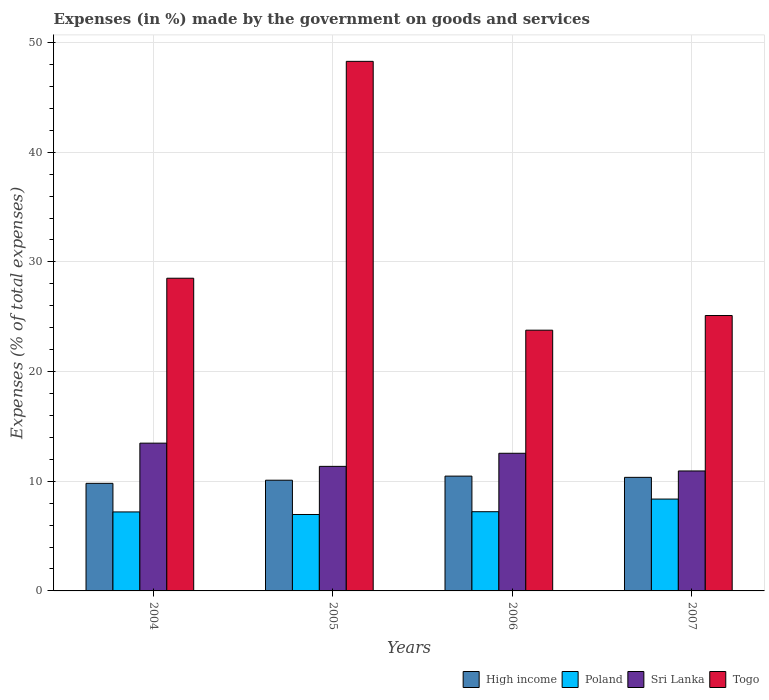How many groups of bars are there?
Your answer should be compact. 4. Are the number of bars per tick equal to the number of legend labels?
Your response must be concise. Yes. What is the label of the 1st group of bars from the left?
Offer a terse response. 2004. In how many cases, is the number of bars for a given year not equal to the number of legend labels?
Your response must be concise. 0. What is the percentage of expenses made by the government on goods and services in Poland in 2006?
Provide a succinct answer. 7.22. Across all years, what is the maximum percentage of expenses made by the government on goods and services in High income?
Offer a very short reply. 10.47. Across all years, what is the minimum percentage of expenses made by the government on goods and services in Togo?
Give a very brief answer. 23.77. In which year was the percentage of expenses made by the government on goods and services in High income minimum?
Your answer should be compact. 2004. What is the total percentage of expenses made by the government on goods and services in High income in the graph?
Ensure brevity in your answer.  40.73. What is the difference between the percentage of expenses made by the government on goods and services in Togo in 2004 and that in 2006?
Give a very brief answer. 4.74. What is the difference between the percentage of expenses made by the government on goods and services in High income in 2005 and the percentage of expenses made by the government on goods and services in Poland in 2004?
Make the answer very short. 2.89. What is the average percentage of expenses made by the government on goods and services in Poland per year?
Keep it short and to the point. 7.44. In the year 2007, what is the difference between the percentage of expenses made by the government on goods and services in Togo and percentage of expenses made by the government on goods and services in Sri Lanka?
Provide a succinct answer. 14.17. In how many years, is the percentage of expenses made by the government on goods and services in High income greater than 26 %?
Your answer should be very brief. 0. What is the ratio of the percentage of expenses made by the government on goods and services in Poland in 2004 to that in 2006?
Provide a short and direct response. 1. Is the percentage of expenses made by the government on goods and services in Sri Lanka in 2004 less than that in 2005?
Make the answer very short. No. Is the difference between the percentage of expenses made by the government on goods and services in Togo in 2005 and 2007 greater than the difference between the percentage of expenses made by the government on goods and services in Sri Lanka in 2005 and 2007?
Your response must be concise. Yes. What is the difference between the highest and the second highest percentage of expenses made by the government on goods and services in High income?
Keep it short and to the point. 0.11. What is the difference between the highest and the lowest percentage of expenses made by the government on goods and services in Togo?
Your answer should be compact. 24.51. Is the sum of the percentage of expenses made by the government on goods and services in Togo in 2004 and 2006 greater than the maximum percentage of expenses made by the government on goods and services in Sri Lanka across all years?
Ensure brevity in your answer.  Yes. Is it the case that in every year, the sum of the percentage of expenses made by the government on goods and services in Togo and percentage of expenses made by the government on goods and services in High income is greater than the sum of percentage of expenses made by the government on goods and services in Sri Lanka and percentage of expenses made by the government on goods and services in Poland?
Keep it short and to the point. Yes. What does the 3rd bar from the left in 2006 represents?
Offer a terse response. Sri Lanka. How many bars are there?
Provide a short and direct response. 16. Are all the bars in the graph horizontal?
Give a very brief answer. No. Are the values on the major ticks of Y-axis written in scientific E-notation?
Your response must be concise. No. Does the graph contain any zero values?
Your answer should be very brief. No. Does the graph contain grids?
Your answer should be very brief. Yes. Where does the legend appear in the graph?
Your response must be concise. Bottom right. How many legend labels are there?
Your response must be concise. 4. What is the title of the graph?
Give a very brief answer. Expenses (in %) made by the government on goods and services. Does "Swaziland" appear as one of the legend labels in the graph?
Your answer should be very brief. No. What is the label or title of the X-axis?
Make the answer very short. Years. What is the label or title of the Y-axis?
Your answer should be very brief. Expenses (% of total expenses). What is the Expenses (% of total expenses) in High income in 2004?
Offer a terse response. 9.81. What is the Expenses (% of total expenses) of Poland in 2004?
Your answer should be compact. 7.2. What is the Expenses (% of total expenses) in Sri Lanka in 2004?
Ensure brevity in your answer.  13.47. What is the Expenses (% of total expenses) in Togo in 2004?
Give a very brief answer. 28.51. What is the Expenses (% of total expenses) in High income in 2005?
Your answer should be compact. 10.09. What is the Expenses (% of total expenses) in Poland in 2005?
Provide a short and direct response. 6.97. What is the Expenses (% of total expenses) of Sri Lanka in 2005?
Your answer should be compact. 11.36. What is the Expenses (% of total expenses) in Togo in 2005?
Provide a short and direct response. 48.29. What is the Expenses (% of total expenses) of High income in 2006?
Your response must be concise. 10.47. What is the Expenses (% of total expenses) of Poland in 2006?
Ensure brevity in your answer.  7.22. What is the Expenses (% of total expenses) in Sri Lanka in 2006?
Give a very brief answer. 12.55. What is the Expenses (% of total expenses) in Togo in 2006?
Provide a short and direct response. 23.77. What is the Expenses (% of total expenses) of High income in 2007?
Keep it short and to the point. 10.36. What is the Expenses (% of total expenses) in Poland in 2007?
Your response must be concise. 8.37. What is the Expenses (% of total expenses) in Sri Lanka in 2007?
Provide a succinct answer. 10.94. What is the Expenses (% of total expenses) of Togo in 2007?
Keep it short and to the point. 25.11. Across all years, what is the maximum Expenses (% of total expenses) in High income?
Keep it short and to the point. 10.47. Across all years, what is the maximum Expenses (% of total expenses) in Poland?
Your answer should be compact. 8.37. Across all years, what is the maximum Expenses (% of total expenses) of Sri Lanka?
Your answer should be compact. 13.47. Across all years, what is the maximum Expenses (% of total expenses) in Togo?
Your answer should be very brief. 48.29. Across all years, what is the minimum Expenses (% of total expenses) in High income?
Offer a terse response. 9.81. Across all years, what is the minimum Expenses (% of total expenses) of Poland?
Provide a short and direct response. 6.97. Across all years, what is the minimum Expenses (% of total expenses) of Sri Lanka?
Ensure brevity in your answer.  10.94. Across all years, what is the minimum Expenses (% of total expenses) of Togo?
Your answer should be compact. 23.77. What is the total Expenses (% of total expenses) of High income in the graph?
Provide a short and direct response. 40.73. What is the total Expenses (% of total expenses) in Poland in the graph?
Ensure brevity in your answer.  29.77. What is the total Expenses (% of total expenses) in Sri Lanka in the graph?
Make the answer very short. 48.32. What is the total Expenses (% of total expenses) in Togo in the graph?
Provide a short and direct response. 125.68. What is the difference between the Expenses (% of total expenses) of High income in 2004 and that in 2005?
Provide a short and direct response. -0.29. What is the difference between the Expenses (% of total expenses) in Poland in 2004 and that in 2005?
Your answer should be very brief. 0.23. What is the difference between the Expenses (% of total expenses) in Sri Lanka in 2004 and that in 2005?
Make the answer very short. 2.12. What is the difference between the Expenses (% of total expenses) in Togo in 2004 and that in 2005?
Your response must be concise. -19.77. What is the difference between the Expenses (% of total expenses) of High income in 2004 and that in 2006?
Your answer should be very brief. -0.66. What is the difference between the Expenses (% of total expenses) of Poland in 2004 and that in 2006?
Keep it short and to the point. -0.02. What is the difference between the Expenses (% of total expenses) in Sri Lanka in 2004 and that in 2006?
Keep it short and to the point. 0.92. What is the difference between the Expenses (% of total expenses) of Togo in 2004 and that in 2006?
Make the answer very short. 4.74. What is the difference between the Expenses (% of total expenses) in High income in 2004 and that in 2007?
Give a very brief answer. -0.55. What is the difference between the Expenses (% of total expenses) in Poland in 2004 and that in 2007?
Offer a very short reply. -1.17. What is the difference between the Expenses (% of total expenses) of Sri Lanka in 2004 and that in 2007?
Keep it short and to the point. 2.53. What is the difference between the Expenses (% of total expenses) of Togo in 2004 and that in 2007?
Offer a terse response. 3.4. What is the difference between the Expenses (% of total expenses) of High income in 2005 and that in 2006?
Make the answer very short. -0.37. What is the difference between the Expenses (% of total expenses) of Poland in 2005 and that in 2006?
Keep it short and to the point. -0.25. What is the difference between the Expenses (% of total expenses) of Sri Lanka in 2005 and that in 2006?
Make the answer very short. -1.19. What is the difference between the Expenses (% of total expenses) of Togo in 2005 and that in 2006?
Your answer should be very brief. 24.51. What is the difference between the Expenses (% of total expenses) of High income in 2005 and that in 2007?
Keep it short and to the point. -0.26. What is the difference between the Expenses (% of total expenses) in Poland in 2005 and that in 2007?
Provide a short and direct response. -1.41. What is the difference between the Expenses (% of total expenses) of Sri Lanka in 2005 and that in 2007?
Keep it short and to the point. 0.42. What is the difference between the Expenses (% of total expenses) of Togo in 2005 and that in 2007?
Keep it short and to the point. 23.18. What is the difference between the Expenses (% of total expenses) of High income in 2006 and that in 2007?
Ensure brevity in your answer.  0.11. What is the difference between the Expenses (% of total expenses) in Poland in 2006 and that in 2007?
Offer a very short reply. -1.15. What is the difference between the Expenses (% of total expenses) of Sri Lanka in 2006 and that in 2007?
Your answer should be compact. 1.61. What is the difference between the Expenses (% of total expenses) of Togo in 2006 and that in 2007?
Your answer should be very brief. -1.34. What is the difference between the Expenses (% of total expenses) in High income in 2004 and the Expenses (% of total expenses) in Poland in 2005?
Your response must be concise. 2.84. What is the difference between the Expenses (% of total expenses) in High income in 2004 and the Expenses (% of total expenses) in Sri Lanka in 2005?
Offer a terse response. -1.55. What is the difference between the Expenses (% of total expenses) of High income in 2004 and the Expenses (% of total expenses) of Togo in 2005?
Provide a short and direct response. -38.48. What is the difference between the Expenses (% of total expenses) of Poland in 2004 and the Expenses (% of total expenses) of Sri Lanka in 2005?
Offer a very short reply. -4.15. What is the difference between the Expenses (% of total expenses) in Poland in 2004 and the Expenses (% of total expenses) in Togo in 2005?
Make the answer very short. -41.08. What is the difference between the Expenses (% of total expenses) of Sri Lanka in 2004 and the Expenses (% of total expenses) of Togo in 2005?
Offer a very short reply. -34.81. What is the difference between the Expenses (% of total expenses) of High income in 2004 and the Expenses (% of total expenses) of Poland in 2006?
Offer a very short reply. 2.59. What is the difference between the Expenses (% of total expenses) in High income in 2004 and the Expenses (% of total expenses) in Sri Lanka in 2006?
Your answer should be compact. -2.74. What is the difference between the Expenses (% of total expenses) of High income in 2004 and the Expenses (% of total expenses) of Togo in 2006?
Keep it short and to the point. -13.97. What is the difference between the Expenses (% of total expenses) of Poland in 2004 and the Expenses (% of total expenses) of Sri Lanka in 2006?
Your answer should be compact. -5.35. What is the difference between the Expenses (% of total expenses) of Poland in 2004 and the Expenses (% of total expenses) of Togo in 2006?
Your answer should be compact. -16.57. What is the difference between the Expenses (% of total expenses) in Sri Lanka in 2004 and the Expenses (% of total expenses) in Togo in 2006?
Keep it short and to the point. -10.3. What is the difference between the Expenses (% of total expenses) in High income in 2004 and the Expenses (% of total expenses) in Poland in 2007?
Provide a succinct answer. 1.43. What is the difference between the Expenses (% of total expenses) in High income in 2004 and the Expenses (% of total expenses) in Sri Lanka in 2007?
Provide a short and direct response. -1.13. What is the difference between the Expenses (% of total expenses) in High income in 2004 and the Expenses (% of total expenses) in Togo in 2007?
Offer a very short reply. -15.3. What is the difference between the Expenses (% of total expenses) in Poland in 2004 and the Expenses (% of total expenses) in Sri Lanka in 2007?
Ensure brevity in your answer.  -3.74. What is the difference between the Expenses (% of total expenses) in Poland in 2004 and the Expenses (% of total expenses) in Togo in 2007?
Your response must be concise. -17.91. What is the difference between the Expenses (% of total expenses) in Sri Lanka in 2004 and the Expenses (% of total expenses) in Togo in 2007?
Provide a short and direct response. -11.64. What is the difference between the Expenses (% of total expenses) of High income in 2005 and the Expenses (% of total expenses) of Poland in 2006?
Your answer should be very brief. 2.87. What is the difference between the Expenses (% of total expenses) of High income in 2005 and the Expenses (% of total expenses) of Sri Lanka in 2006?
Offer a very short reply. -2.46. What is the difference between the Expenses (% of total expenses) of High income in 2005 and the Expenses (% of total expenses) of Togo in 2006?
Ensure brevity in your answer.  -13.68. What is the difference between the Expenses (% of total expenses) in Poland in 2005 and the Expenses (% of total expenses) in Sri Lanka in 2006?
Give a very brief answer. -5.58. What is the difference between the Expenses (% of total expenses) in Poland in 2005 and the Expenses (% of total expenses) in Togo in 2006?
Offer a very short reply. -16.81. What is the difference between the Expenses (% of total expenses) in Sri Lanka in 2005 and the Expenses (% of total expenses) in Togo in 2006?
Provide a succinct answer. -12.42. What is the difference between the Expenses (% of total expenses) in High income in 2005 and the Expenses (% of total expenses) in Poland in 2007?
Keep it short and to the point. 1.72. What is the difference between the Expenses (% of total expenses) of High income in 2005 and the Expenses (% of total expenses) of Sri Lanka in 2007?
Your response must be concise. -0.84. What is the difference between the Expenses (% of total expenses) in High income in 2005 and the Expenses (% of total expenses) in Togo in 2007?
Keep it short and to the point. -15.02. What is the difference between the Expenses (% of total expenses) of Poland in 2005 and the Expenses (% of total expenses) of Sri Lanka in 2007?
Keep it short and to the point. -3.97. What is the difference between the Expenses (% of total expenses) in Poland in 2005 and the Expenses (% of total expenses) in Togo in 2007?
Provide a short and direct response. -18.14. What is the difference between the Expenses (% of total expenses) of Sri Lanka in 2005 and the Expenses (% of total expenses) of Togo in 2007?
Ensure brevity in your answer.  -13.75. What is the difference between the Expenses (% of total expenses) of High income in 2006 and the Expenses (% of total expenses) of Poland in 2007?
Give a very brief answer. 2.09. What is the difference between the Expenses (% of total expenses) in High income in 2006 and the Expenses (% of total expenses) in Sri Lanka in 2007?
Offer a terse response. -0.47. What is the difference between the Expenses (% of total expenses) of High income in 2006 and the Expenses (% of total expenses) of Togo in 2007?
Provide a succinct answer. -14.64. What is the difference between the Expenses (% of total expenses) of Poland in 2006 and the Expenses (% of total expenses) of Sri Lanka in 2007?
Provide a short and direct response. -3.72. What is the difference between the Expenses (% of total expenses) in Poland in 2006 and the Expenses (% of total expenses) in Togo in 2007?
Keep it short and to the point. -17.89. What is the difference between the Expenses (% of total expenses) in Sri Lanka in 2006 and the Expenses (% of total expenses) in Togo in 2007?
Your answer should be very brief. -12.56. What is the average Expenses (% of total expenses) of High income per year?
Your response must be concise. 10.18. What is the average Expenses (% of total expenses) of Poland per year?
Keep it short and to the point. 7.44. What is the average Expenses (% of total expenses) of Sri Lanka per year?
Your response must be concise. 12.08. What is the average Expenses (% of total expenses) in Togo per year?
Your response must be concise. 31.42. In the year 2004, what is the difference between the Expenses (% of total expenses) of High income and Expenses (% of total expenses) of Poland?
Your response must be concise. 2.61. In the year 2004, what is the difference between the Expenses (% of total expenses) in High income and Expenses (% of total expenses) in Sri Lanka?
Keep it short and to the point. -3.66. In the year 2004, what is the difference between the Expenses (% of total expenses) in High income and Expenses (% of total expenses) in Togo?
Provide a short and direct response. -18.7. In the year 2004, what is the difference between the Expenses (% of total expenses) in Poland and Expenses (% of total expenses) in Sri Lanka?
Keep it short and to the point. -6.27. In the year 2004, what is the difference between the Expenses (% of total expenses) in Poland and Expenses (% of total expenses) in Togo?
Keep it short and to the point. -21.31. In the year 2004, what is the difference between the Expenses (% of total expenses) in Sri Lanka and Expenses (% of total expenses) in Togo?
Provide a short and direct response. -15.04. In the year 2005, what is the difference between the Expenses (% of total expenses) in High income and Expenses (% of total expenses) in Poland?
Offer a very short reply. 3.13. In the year 2005, what is the difference between the Expenses (% of total expenses) in High income and Expenses (% of total expenses) in Sri Lanka?
Offer a terse response. -1.26. In the year 2005, what is the difference between the Expenses (% of total expenses) in High income and Expenses (% of total expenses) in Togo?
Make the answer very short. -38.19. In the year 2005, what is the difference between the Expenses (% of total expenses) of Poland and Expenses (% of total expenses) of Sri Lanka?
Your response must be concise. -4.39. In the year 2005, what is the difference between the Expenses (% of total expenses) of Poland and Expenses (% of total expenses) of Togo?
Keep it short and to the point. -41.32. In the year 2005, what is the difference between the Expenses (% of total expenses) in Sri Lanka and Expenses (% of total expenses) in Togo?
Your answer should be very brief. -36.93. In the year 2006, what is the difference between the Expenses (% of total expenses) in High income and Expenses (% of total expenses) in Poland?
Offer a terse response. 3.25. In the year 2006, what is the difference between the Expenses (% of total expenses) in High income and Expenses (% of total expenses) in Sri Lanka?
Make the answer very short. -2.08. In the year 2006, what is the difference between the Expenses (% of total expenses) in High income and Expenses (% of total expenses) in Togo?
Make the answer very short. -13.31. In the year 2006, what is the difference between the Expenses (% of total expenses) of Poland and Expenses (% of total expenses) of Sri Lanka?
Your answer should be very brief. -5.33. In the year 2006, what is the difference between the Expenses (% of total expenses) in Poland and Expenses (% of total expenses) in Togo?
Give a very brief answer. -16.55. In the year 2006, what is the difference between the Expenses (% of total expenses) of Sri Lanka and Expenses (% of total expenses) of Togo?
Offer a terse response. -11.22. In the year 2007, what is the difference between the Expenses (% of total expenses) in High income and Expenses (% of total expenses) in Poland?
Offer a very short reply. 1.98. In the year 2007, what is the difference between the Expenses (% of total expenses) in High income and Expenses (% of total expenses) in Sri Lanka?
Your answer should be compact. -0.58. In the year 2007, what is the difference between the Expenses (% of total expenses) of High income and Expenses (% of total expenses) of Togo?
Offer a terse response. -14.75. In the year 2007, what is the difference between the Expenses (% of total expenses) in Poland and Expenses (% of total expenses) in Sri Lanka?
Ensure brevity in your answer.  -2.56. In the year 2007, what is the difference between the Expenses (% of total expenses) of Poland and Expenses (% of total expenses) of Togo?
Provide a succinct answer. -16.74. In the year 2007, what is the difference between the Expenses (% of total expenses) of Sri Lanka and Expenses (% of total expenses) of Togo?
Offer a terse response. -14.17. What is the ratio of the Expenses (% of total expenses) of High income in 2004 to that in 2005?
Offer a very short reply. 0.97. What is the ratio of the Expenses (% of total expenses) of Poland in 2004 to that in 2005?
Offer a very short reply. 1.03. What is the ratio of the Expenses (% of total expenses) of Sri Lanka in 2004 to that in 2005?
Your response must be concise. 1.19. What is the ratio of the Expenses (% of total expenses) in Togo in 2004 to that in 2005?
Keep it short and to the point. 0.59. What is the ratio of the Expenses (% of total expenses) in High income in 2004 to that in 2006?
Your answer should be compact. 0.94. What is the ratio of the Expenses (% of total expenses) of Poland in 2004 to that in 2006?
Your answer should be compact. 1. What is the ratio of the Expenses (% of total expenses) in Sri Lanka in 2004 to that in 2006?
Give a very brief answer. 1.07. What is the ratio of the Expenses (% of total expenses) in Togo in 2004 to that in 2006?
Your answer should be compact. 1.2. What is the ratio of the Expenses (% of total expenses) in High income in 2004 to that in 2007?
Offer a very short reply. 0.95. What is the ratio of the Expenses (% of total expenses) in Poland in 2004 to that in 2007?
Your answer should be compact. 0.86. What is the ratio of the Expenses (% of total expenses) in Sri Lanka in 2004 to that in 2007?
Your answer should be very brief. 1.23. What is the ratio of the Expenses (% of total expenses) of Togo in 2004 to that in 2007?
Your answer should be very brief. 1.14. What is the ratio of the Expenses (% of total expenses) in High income in 2005 to that in 2006?
Offer a terse response. 0.96. What is the ratio of the Expenses (% of total expenses) in Poland in 2005 to that in 2006?
Ensure brevity in your answer.  0.96. What is the ratio of the Expenses (% of total expenses) of Sri Lanka in 2005 to that in 2006?
Make the answer very short. 0.9. What is the ratio of the Expenses (% of total expenses) of Togo in 2005 to that in 2006?
Give a very brief answer. 2.03. What is the ratio of the Expenses (% of total expenses) of High income in 2005 to that in 2007?
Your answer should be compact. 0.97. What is the ratio of the Expenses (% of total expenses) in Poland in 2005 to that in 2007?
Make the answer very short. 0.83. What is the ratio of the Expenses (% of total expenses) of Sri Lanka in 2005 to that in 2007?
Provide a succinct answer. 1.04. What is the ratio of the Expenses (% of total expenses) in Togo in 2005 to that in 2007?
Give a very brief answer. 1.92. What is the ratio of the Expenses (% of total expenses) in High income in 2006 to that in 2007?
Your answer should be compact. 1.01. What is the ratio of the Expenses (% of total expenses) of Poland in 2006 to that in 2007?
Keep it short and to the point. 0.86. What is the ratio of the Expenses (% of total expenses) in Sri Lanka in 2006 to that in 2007?
Give a very brief answer. 1.15. What is the ratio of the Expenses (% of total expenses) of Togo in 2006 to that in 2007?
Your answer should be very brief. 0.95. What is the difference between the highest and the second highest Expenses (% of total expenses) in High income?
Make the answer very short. 0.11. What is the difference between the highest and the second highest Expenses (% of total expenses) in Poland?
Offer a terse response. 1.15. What is the difference between the highest and the second highest Expenses (% of total expenses) in Sri Lanka?
Offer a terse response. 0.92. What is the difference between the highest and the second highest Expenses (% of total expenses) of Togo?
Your response must be concise. 19.77. What is the difference between the highest and the lowest Expenses (% of total expenses) of High income?
Keep it short and to the point. 0.66. What is the difference between the highest and the lowest Expenses (% of total expenses) in Poland?
Make the answer very short. 1.41. What is the difference between the highest and the lowest Expenses (% of total expenses) in Sri Lanka?
Ensure brevity in your answer.  2.53. What is the difference between the highest and the lowest Expenses (% of total expenses) in Togo?
Your response must be concise. 24.51. 